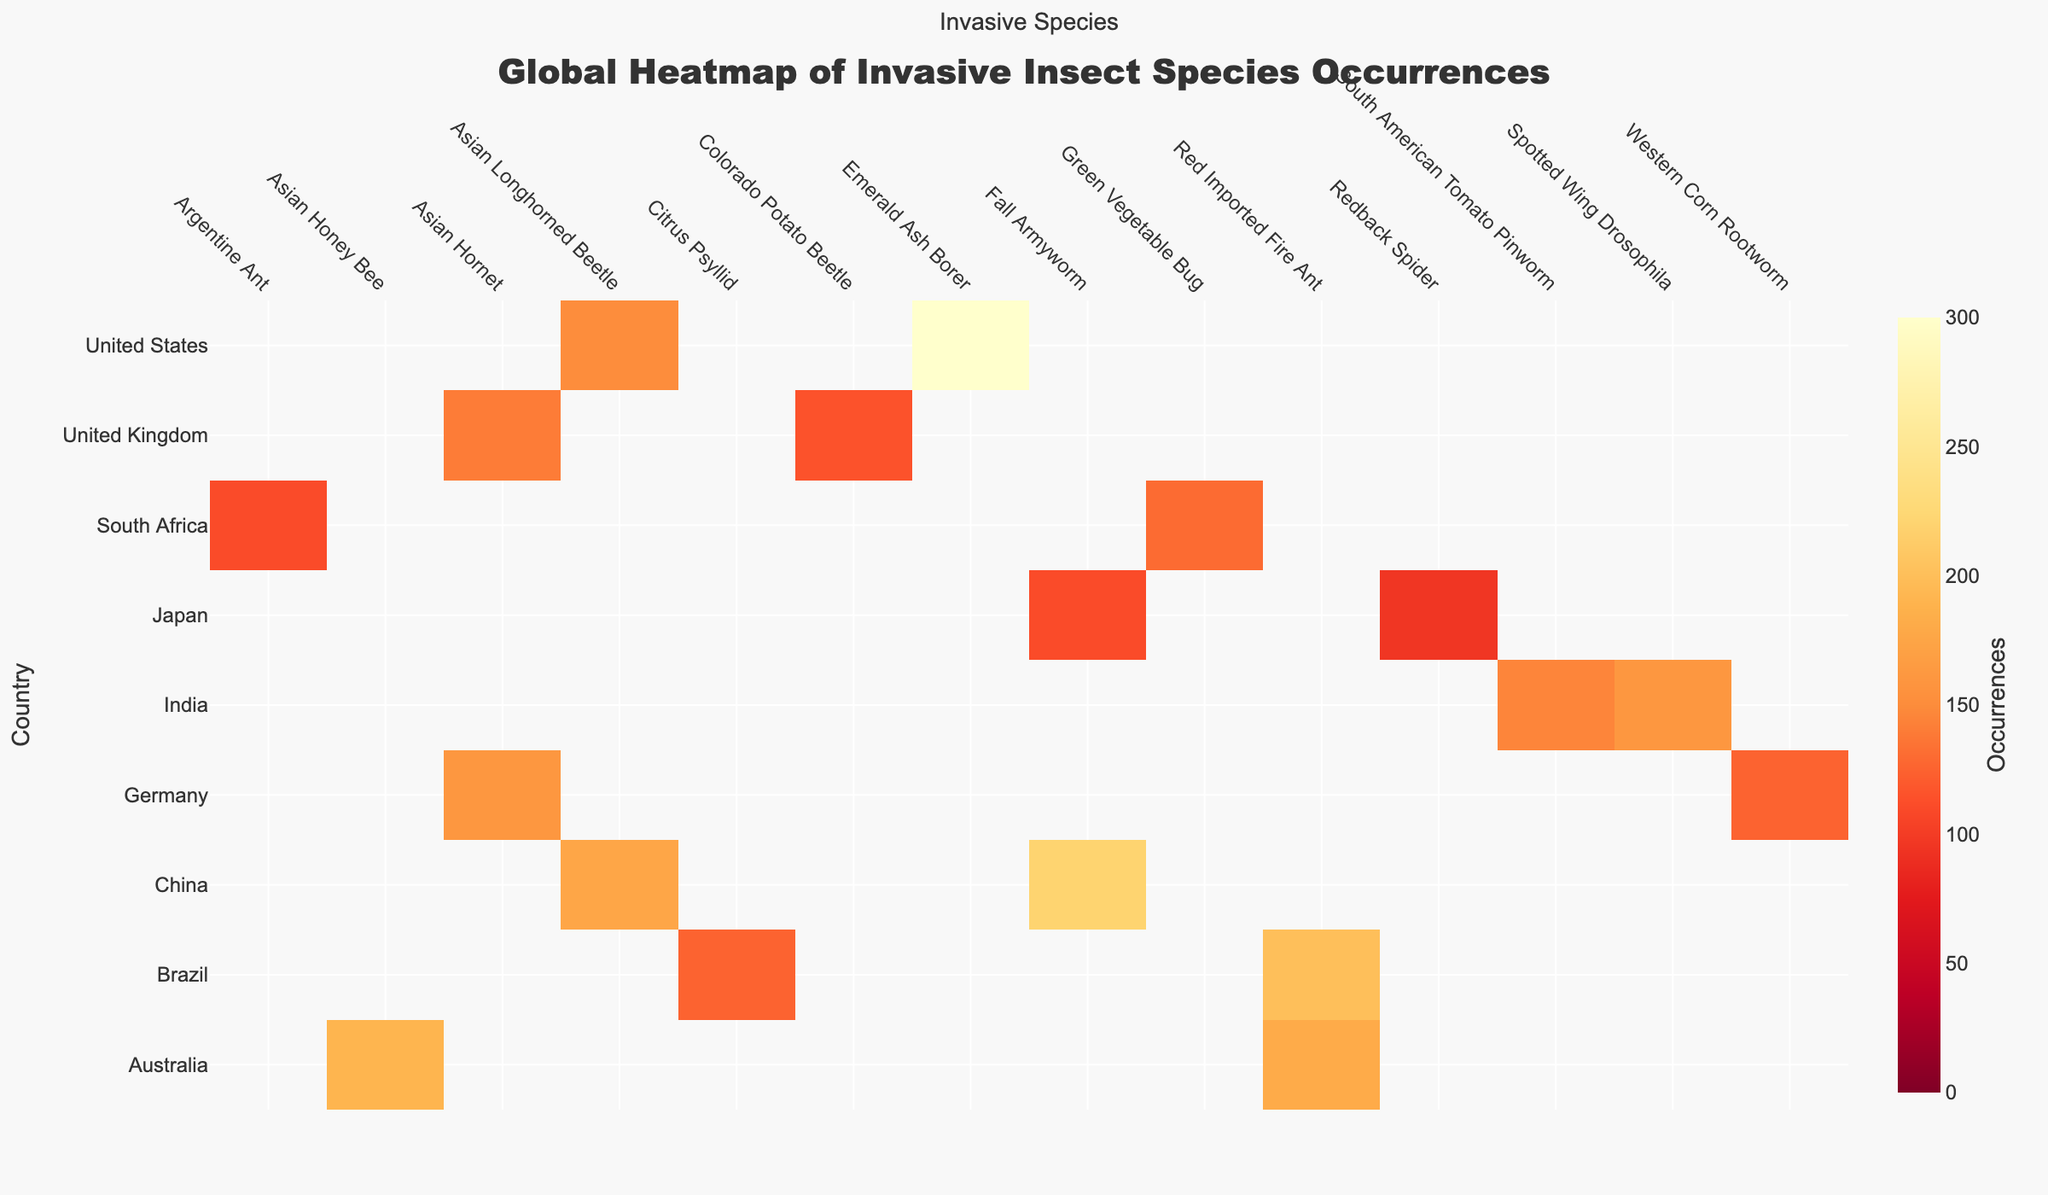What's the title of the heatmap? The title can be found at the top center of the heatmap. The text says 'Global Heatmap of Invasive Insect Species Occurrences'.
Answer: Global Heatmap of Invasive Insect Species Occurrences What is the highest occurrence of an invasive insect species, and which country does it belong to? The darkest red cell in the heatmap indicates the highest value. The United States has the highest occurrence with the Emerald Ash Borer species, occurring 300 times.
Answer: United States Which country has the most diverse set of invasive insect species? To find this, check which country has the most different insect species listed in its row. The United States, Brazil, and Australia each have two different invasive species.
Answer: United States, Brazil, and Australia How many times does the Asian Hornet occur in the United Kingdom and Germany combined? Look at the values for the Asian Hornet in the columns corresponding to the United Kingdom and Germany. Summing these values: 140 (United Kingdom) + 160 (Germany) = 300.
Answer: 300 Which insect species has the highest total occurrences worldwide? Sum the occurrences for each insect species across all countries and compare the totals. The Red Imported Fire Ant appears 200 (Brazil) + 180 (Australia) = 380 times, the highest overall.
Answer: Red Imported Fire Ant Which country has more occurrences of the Fall Armyworm, China or Japan? Review the heatmap values for the Fall Armyworm in the columns for China and Japan. China has 220 occurrences, whereas Japan has 110 occurrences.
Answer: China What is the median number of occurrences for the Spotted Wing Drosophila across all countries? Check all values for Spotted Wing Drosophila and sort them. There is only one value, which is 160 (India), so it is both the minimum, maximum, and median.
Answer: 160 Which country has the second-highest occurrence of the Asian Longhorned Beetle? Identify the rows with occurrences of the Asian Longhorned Beetle. The values are 175 (China) and 150 (United States). The second-highest is China with 175 occurrences.
Answer: China Does Brazil have a higher total occurrence of invasive species than Japan? Summing the values for Brazil: 200 (Red Imported Fire Ant) + 125 (Citrus Psyllid) = 325. Summing the values for Japan: 95 (Redback Spider) + 110 (Fall Armyworm) = 205. Brazil has higher total occurrences.
Answer: Yes How many different invasive insect species are found in China according to the heatmap? Count the number of different species listed in the row for China. The species are Fall Armyworm and Asian Longhorned Beetle, totaling 2.
Answer: 2 